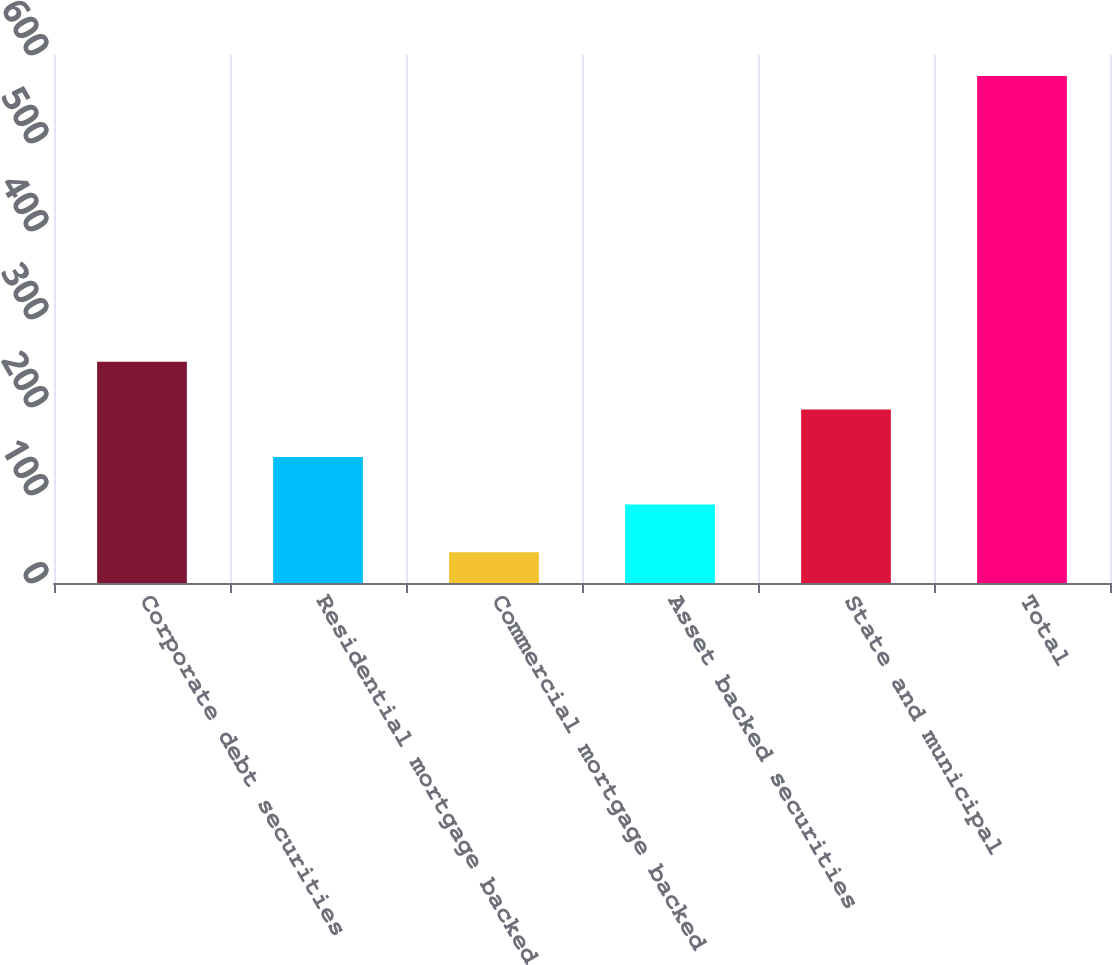<chart> <loc_0><loc_0><loc_500><loc_500><bar_chart><fcel>Corporate debt securities<fcel>Residential mortgage backed<fcel>Commercial mortgage backed<fcel>Asset backed securities<fcel>State and municipal<fcel>Total<nl><fcel>251.4<fcel>143.2<fcel>35<fcel>89.1<fcel>197.3<fcel>576<nl></chart> 